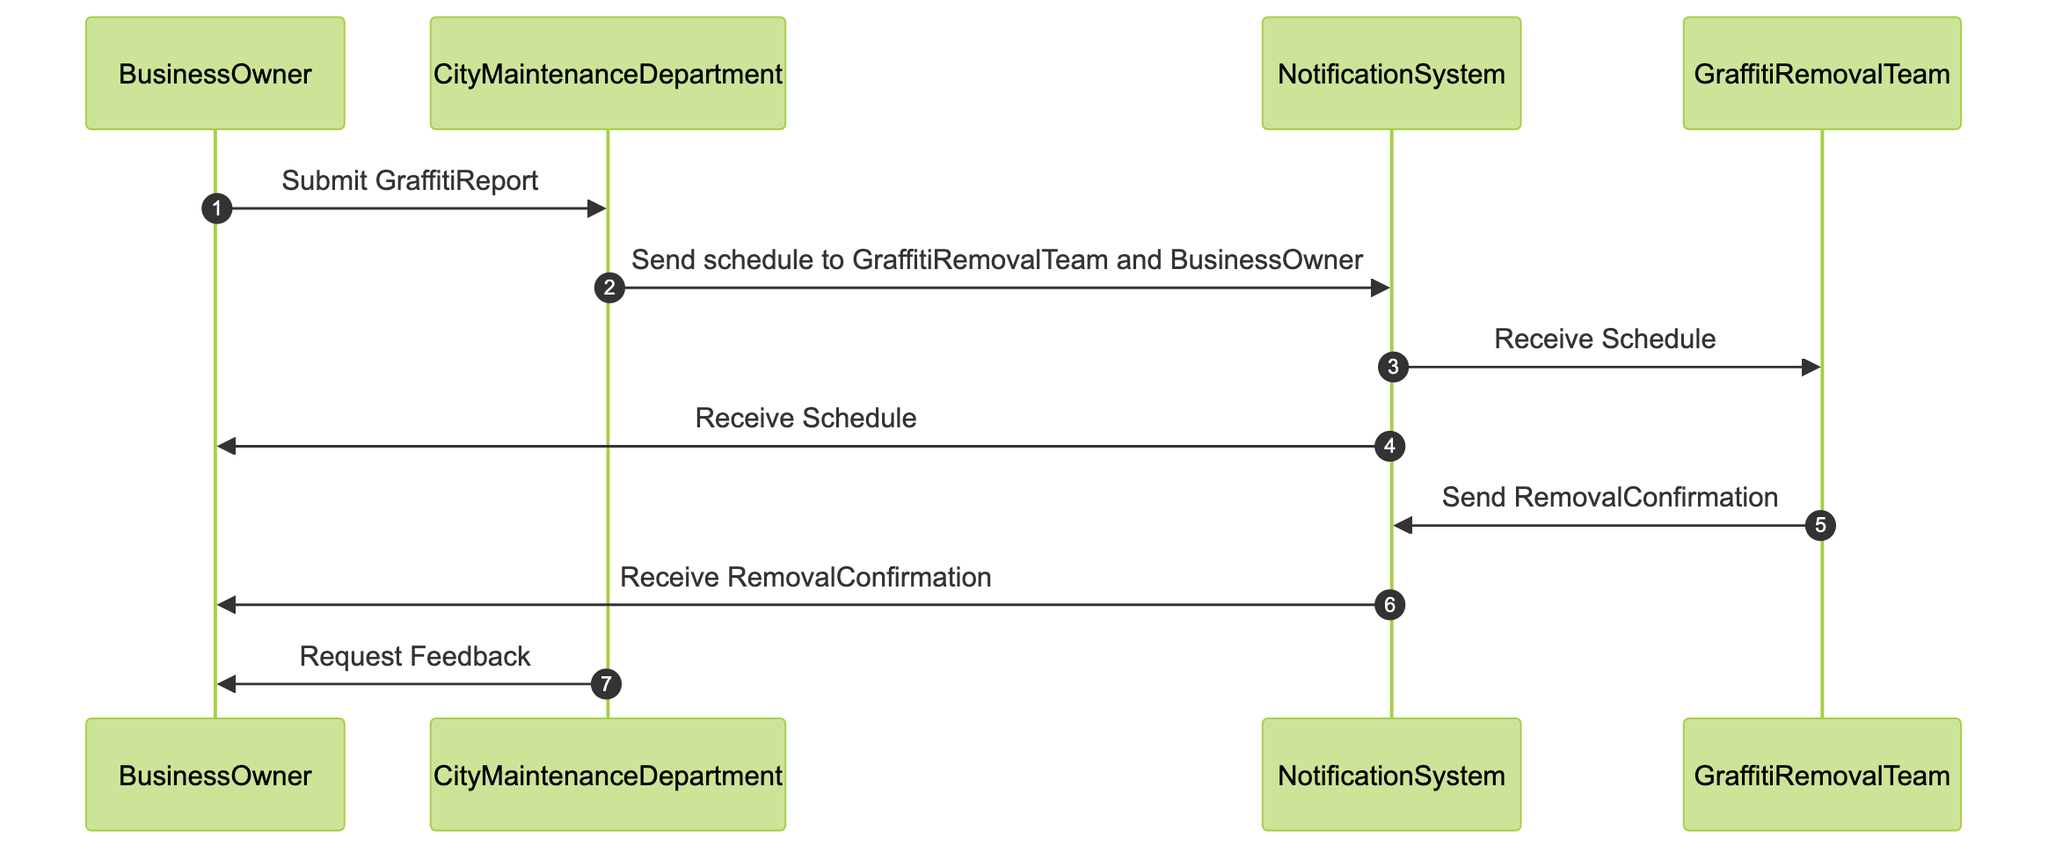What is the first action taken in the sequence? The first action in the sequence is conducted by the BusinessOwner, who submits a GraffitiReport to the CityMaintenanceDepartment. This initiates the process of scheduling and executing graffiti removal.
Answer: Submit GraffitiReport How many participants are involved in the diagram? The diagram includes four participants: BusinessOwner, CityMaintenanceDepartment, NotificationSystem, and GraffitiRemovalTeam.
Answer: Four What message does the CityMaintenanceDepartment send to the NotificationSystem? The CityMaintenanceDepartment sends a message indicating to send the schedule to the GraffitiRemovalTeam and the BusinessOwner, which is an essential step for coordinating the graffiti removal operations.
Answer: Send schedule to GraffitiRemovalTeam and BusinessOwner Which participant receives the RemovalConfirmation? The BusinessOwner receives the RemovalConfirmation from the NotificationSystem after the GraffitiRemovalTeam sends it, indicating that the graffiti has been successfully removed.
Answer: BusinessOwner What action is requested from the BusinessOwner at the end of the sequence? At the end of the sequence, the CityMaintenanceDepartment requests feedback from the BusinessOwner regarding the removal operation. This is important for assessing the quality of the work done.
Answer: Request Feedback What does the NotificationSystem do after receiving the schedule? Upon receiving the schedule, the NotificationSystem distributes it to both the GraffitiRemovalTeam and the BusinessOwner, ensuring all parties are informed about the planned operations.
Answer: Receive Schedule 